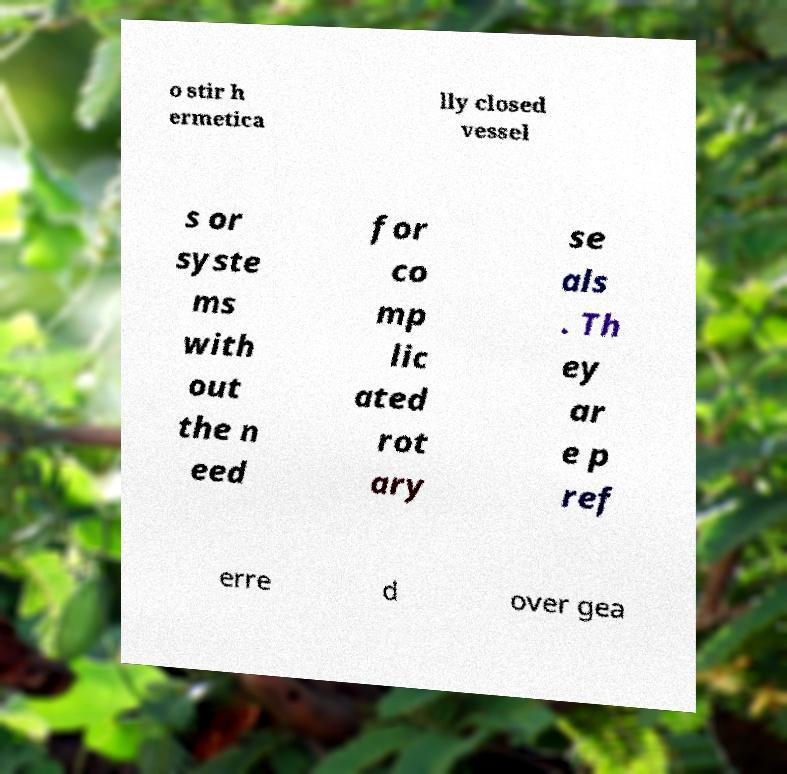Can you accurately transcribe the text from the provided image for me? o stir h ermetica lly closed vessel s or syste ms with out the n eed for co mp lic ated rot ary se als . Th ey ar e p ref erre d over gea 